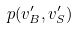<formula> <loc_0><loc_0><loc_500><loc_500>p ( v _ { B } ^ { \prime } , v _ { S } ^ { \prime } )</formula> 